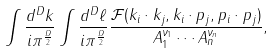<formula> <loc_0><loc_0><loc_500><loc_500>\int \frac { d ^ { D } k } { i \pi ^ { \frac { D } { 2 } } } \int \frac { d ^ { D } \ell } { i \pi ^ { \frac { D } { 2 } } } \frac { { \mathcal { F } } ( k _ { i } \cdot k _ { j } , k _ { i } \cdot p _ { j } , p _ { i } \cdot p _ { j } ) } { A ^ { \nu _ { 1 } } _ { 1 } \cdots A ^ { \nu _ { n } } _ { n } } ,</formula> 